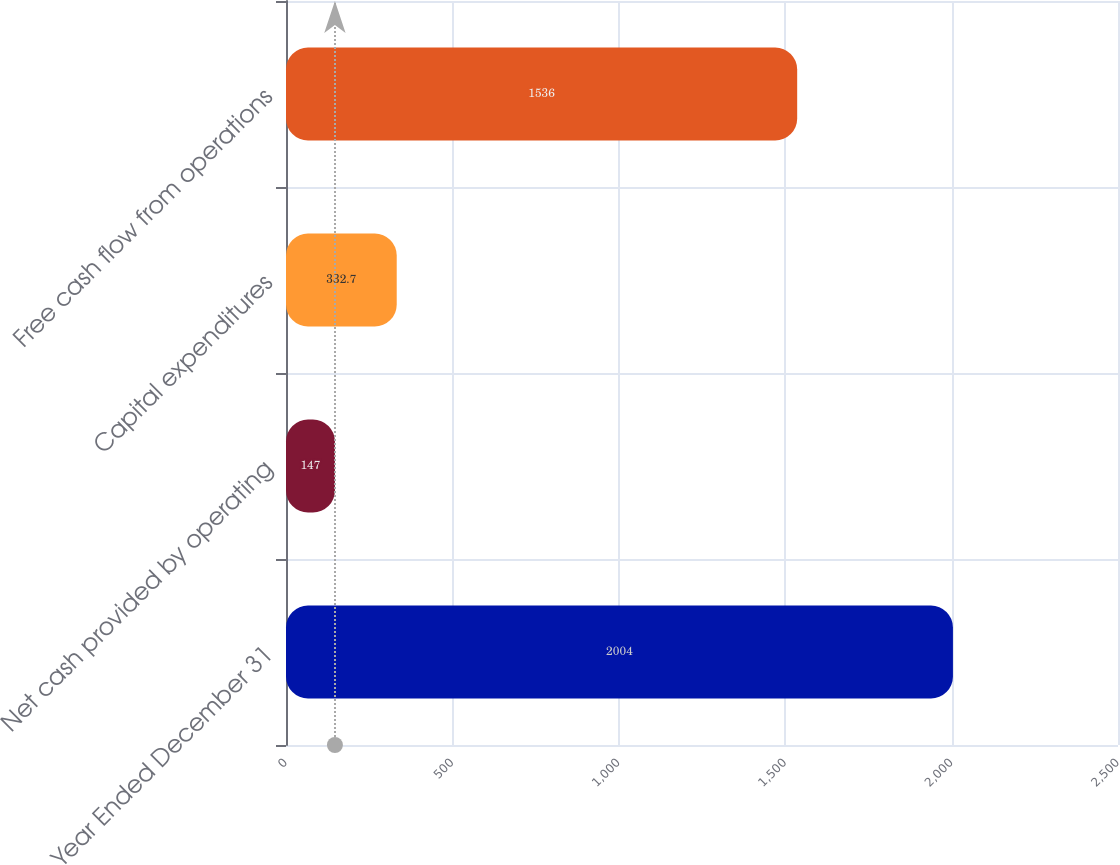Convert chart. <chart><loc_0><loc_0><loc_500><loc_500><bar_chart><fcel>Year Ended December 31<fcel>Net cash provided by operating<fcel>Capital expenditures<fcel>Free cash flow from operations<nl><fcel>2004<fcel>147<fcel>332.7<fcel>1536<nl></chart> 